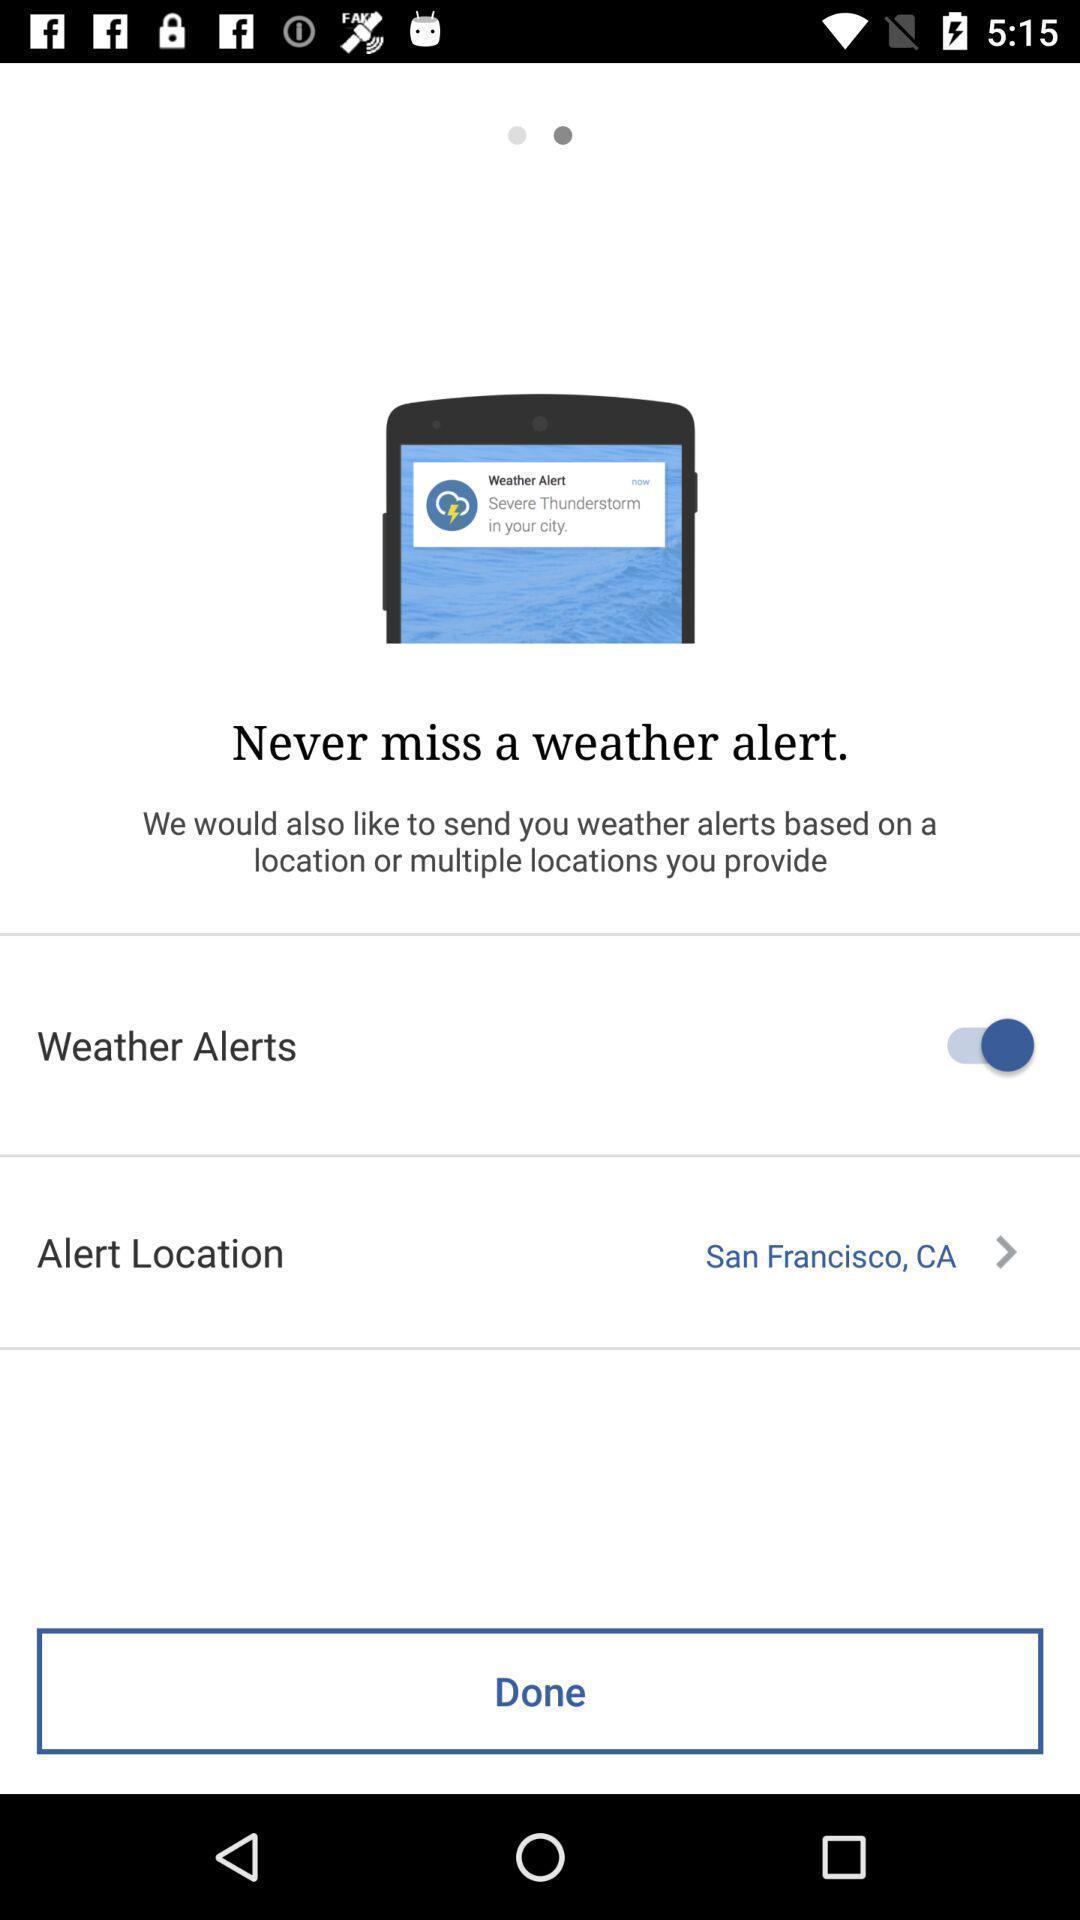Give me a narrative description of this picture. Screen shows weather alerts options. 